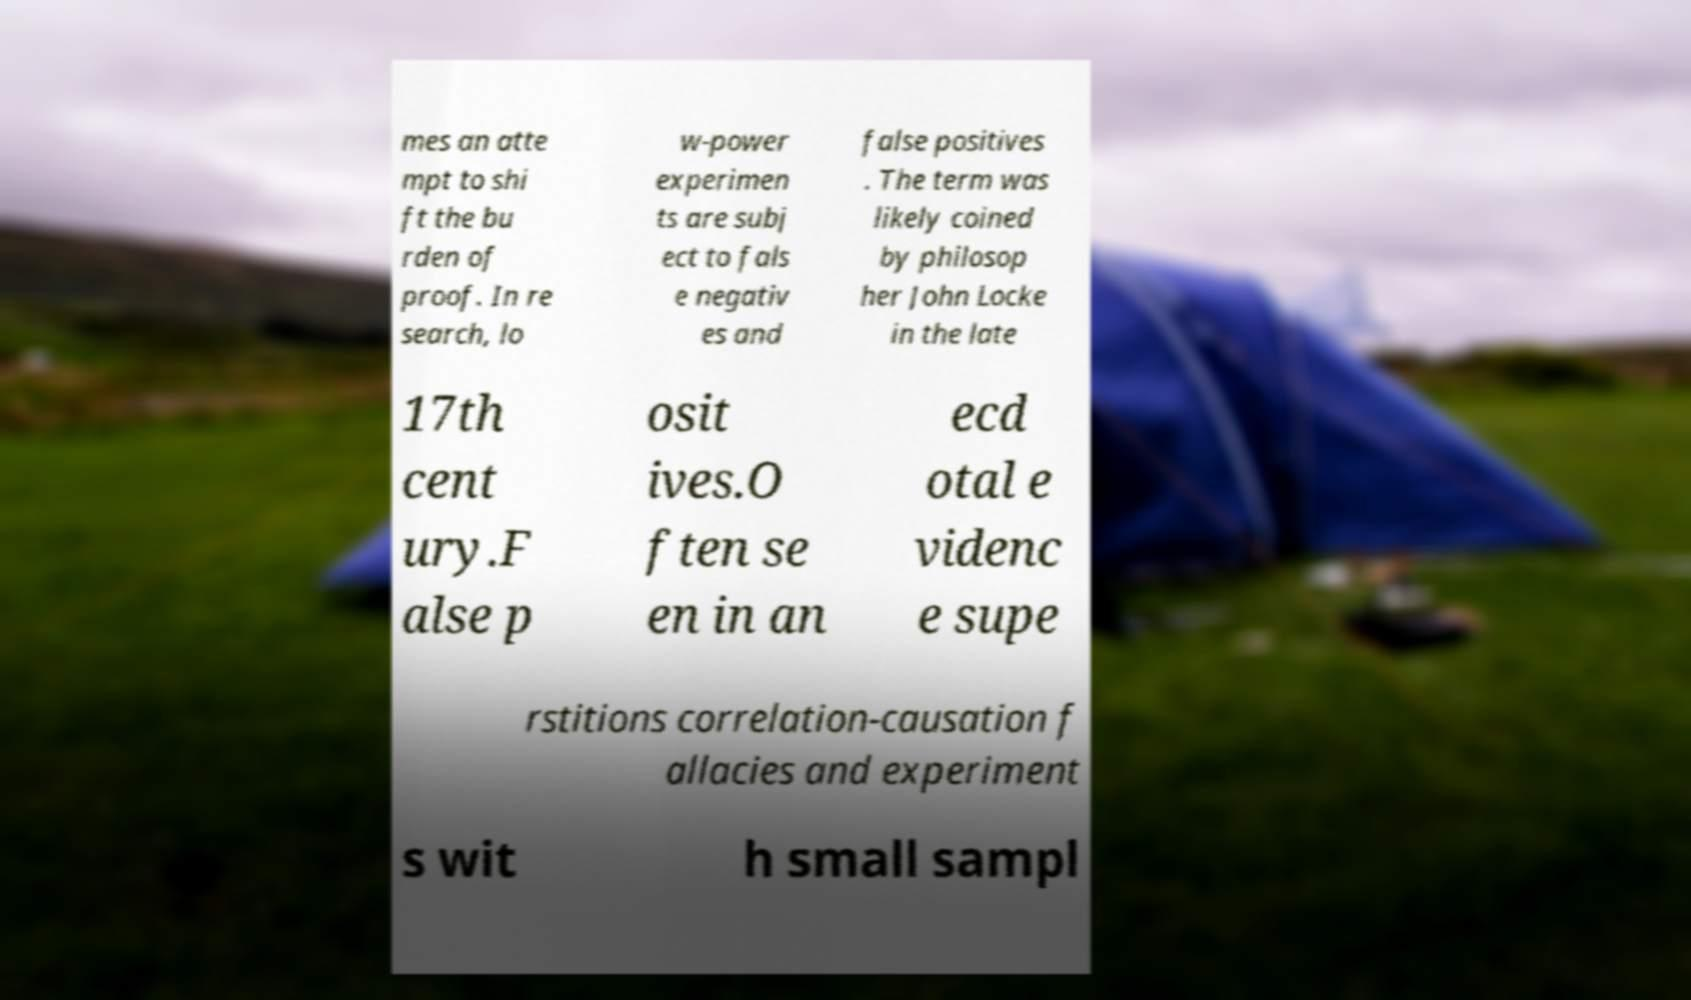For documentation purposes, I need the text within this image transcribed. Could you provide that? mes an atte mpt to shi ft the bu rden of proof. In re search, lo w-power experimen ts are subj ect to fals e negativ es and false positives . The term was likely coined by philosop her John Locke in the late 17th cent ury.F alse p osit ives.O ften se en in an ecd otal e videnc e supe rstitions correlation-causation f allacies and experiment s wit h small sampl 